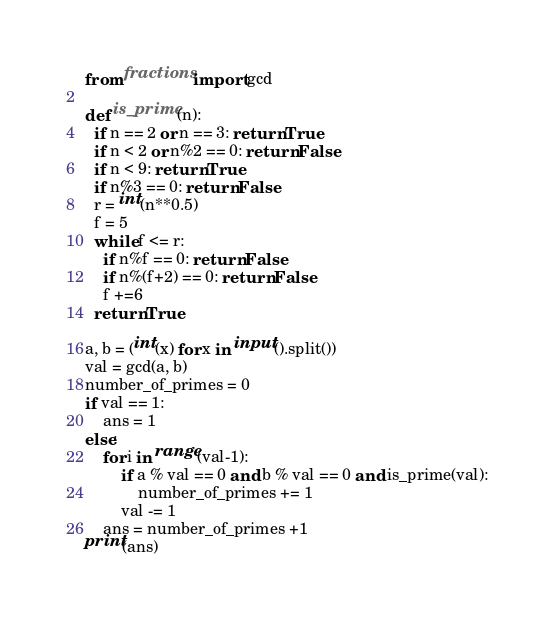<code> <loc_0><loc_0><loc_500><loc_500><_Python_>from fractions import gcd

def is_prime(n):
  if n == 2 or n == 3: return True
  if n < 2 or n%2 == 0: return False
  if n < 9: return True
  if n%3 == 0: return False
  r = int(n**0.5)
  f = 5
  while f <= r:
    if n%f == 0: return False
    if n%(f+2) == 0: return False
    f +=6
  return True  

a, b = (int(x) for x in input().split())
val = gcd(a, b)
number_of_primes = 0
if val == 1:
    ans = 1
else:
    for i in range(val-1):
        if a % val == 0 and b % val == 0 and is_prime(val):
            number_of_primes += 1
        val -= 1
    ans = number_of_primes +1
print(ans) 
</code> 